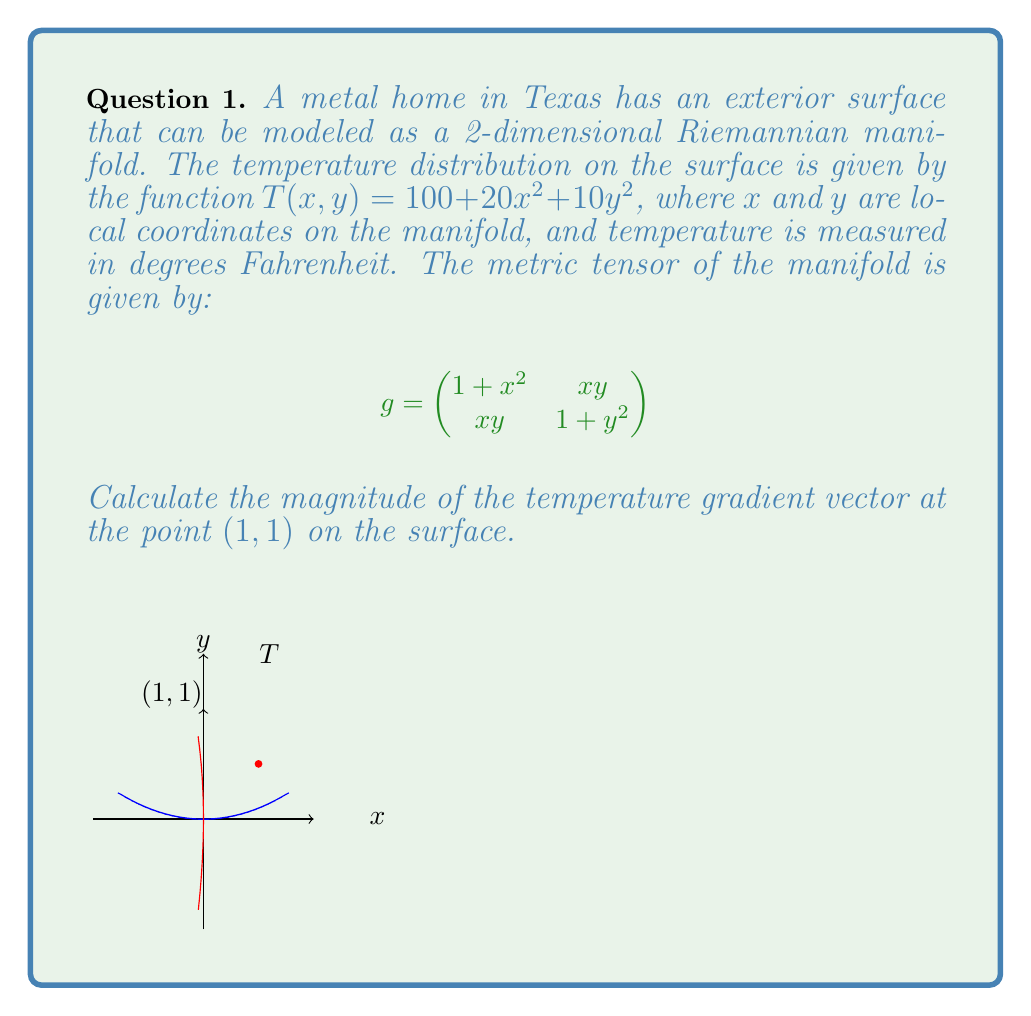Provide a solution to this math problem. To solve this problem, we'll follow these steps:

1) First, we need to calculate the gradient of the temperature function $T(x,y)$ in local coordinates:

   $\nabla T = (\frac{\partial T}{\partial x}, \frac{\partial T}{\partial y}) = (40x, 20y)$

2) At the point (1,1), the gradient vector is:

   $\nabla T|_{(1,1)} = (40, 20)$

3) In a Riemannian manifold, the magnitude of a vector $v = (v^1, v^2)$ is given by:

   $\|v\| = \sqrt{g_{ij}v^iv^j}$

   where $g_{ij}$ are the components of the metric tensor.

4) At the point (1,1), the metric tensor is:

   $$g|_{(1,1)} = \begin{pmatrix}
   2 & 1 \\
   1 & 2
   \end{pmatrix}$$

5) Now we can calculate the magnitude:

   $\|\nabla T\|^2 = g_{11}(v^1)^2 + 2g_{12}v^1v^2 + g_{22}(v^2)^2$

   $= 2(40)^2 + 2(40)(20) + 2(20)^2$

   $= 3200 + 1600 + 800 = 5600$

6) Taking the square root:

   $\|\nabla T\| = \sqrt{5600} = 20\sqrt{14}$ °F/unit length
Answer: $20\sqrt{14}$ °F/unit length 